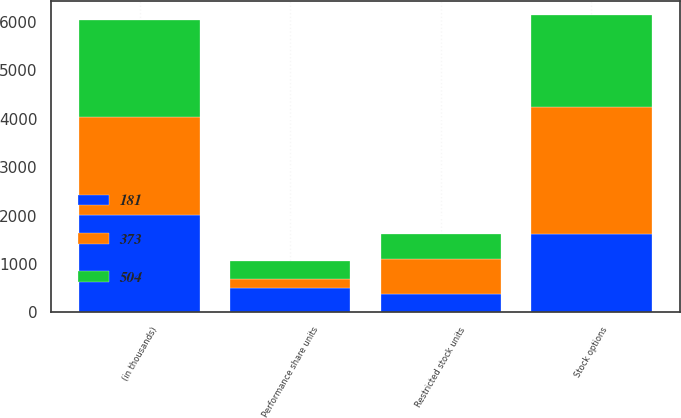Convert chart. <chart><loc_0><loc_0><loc_500><loc_500><stacked_bar_chart><ecel><fcel>(in thousands)<fcel>Stock options<fcel>Restricted stock units<fcel>Performance share units<nl><fcel>181<fcel>2017<fcel>1626<fcel>379<fcel>504<nl><fcel>504<fcel>2016<fcel>1892<fcel>514<fcel>373<nl><fcel>373<fcel>2015<fcel>2616<fcel>723<fcel>181<nl></chart> 